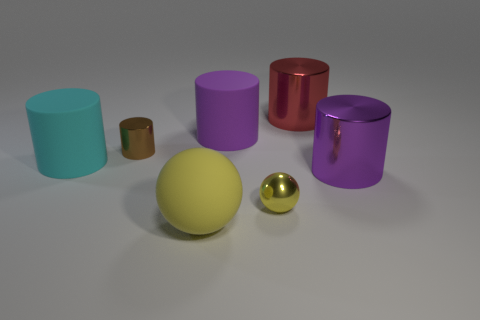Add 1 large rubber objects. How many objects exist? 8 Subtract all purple metal cylinders. How many cylinders are left? 4 Subtract all cyan cylinders. How many cylinders are left? 4 Subtract all cylinders. How many objects are left? 2 Subtract 1 balls. How many balls are left? 1 Subtract all red spheres. How many gray cylinders are left? 0 Subtract all yellow spheres. Subtract all big cylinders. How many objects are left? 1 Add 3 large metal cylinders. How many large metal cylinders are left? 5 Add 3 big shiny balls. How many big shiny balls exist? 3 Subtract 0 cyan spheres. How many objects are left? 7 